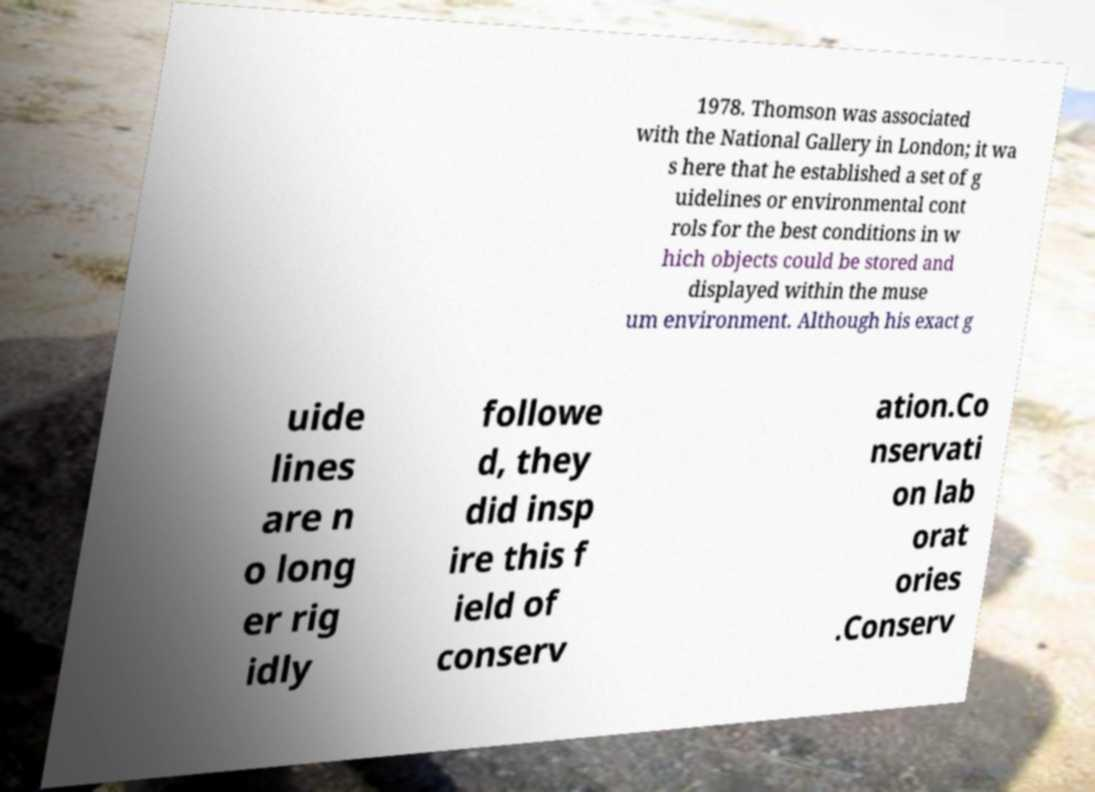Can you accurately transcribe the text from the provided image for me? 1978. Thomson was associated with the National Gallery in London; it wa s here that he established a set of g uidelines or environmental cont rols for the best conditions in w hich objects could be stored and displayed within the muse um environment. Although his exact g uide lines are n o long er rig idly followe d, they did insp ire this f ield of conserv ation.Co nservati on lab orat ories .Conserv 